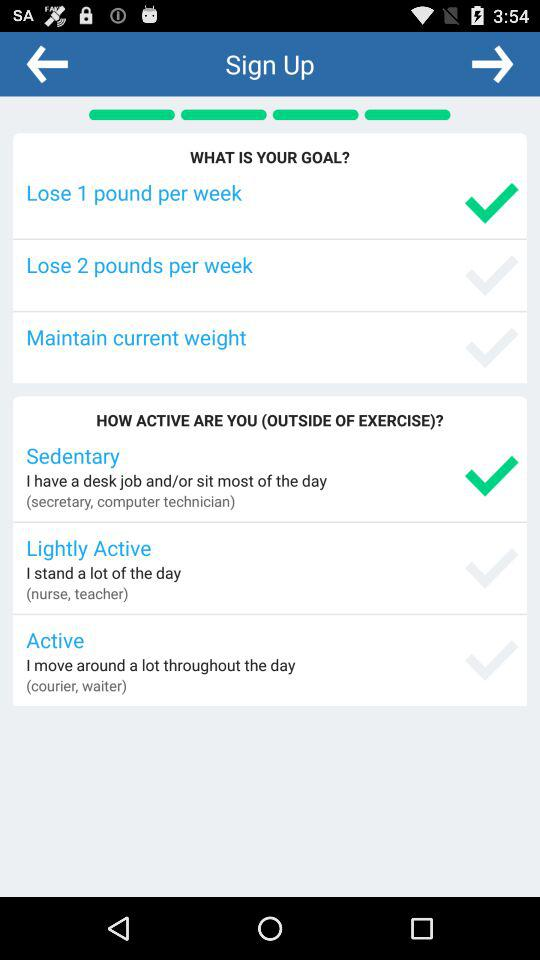Out of Sedentary, Lightly Active and Active, which option is selected? The selected option is "Sedentary". 